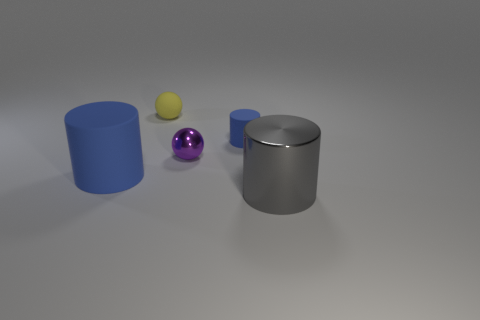Add 1 tiny purple cubes. How many objects exist? 6 Subtract all gray cylinders. How many cylinders are left? 2 Subtract all big rubber cylinders. How many cylinders are left? 2 Subtract 1 gray cylinders. How many objects are left? 4 Subtract all cylinders. How many objects are left? 2 Subtract all gray cylinders. Subtract all green balls. How many cylinders are left? 2 Subtract all purple spheres. How many blue cylinders are left? 2 Subtract all large gray objects. Subtract all large metal things. How many objects are left? 3 Add 1 gray metallic cylinders. How many gray metallic cylinders are left? 2 Add 1 purple matte blocks. How many purple matte blocks exist? 1 